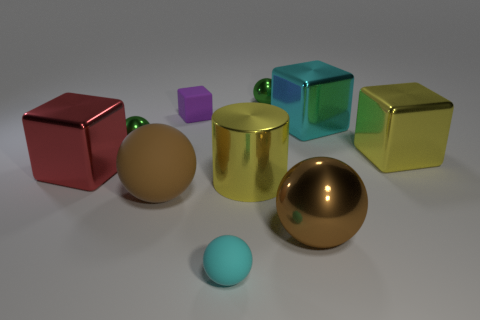Are these objects representing something symbolic, or are they simply a random assortment? The objects might not represent anything symbolic inherently; they are likely a collection of shapes rendered to demonstrate lighting, texture, and reflection properties in a 3D modeling environment. However, one could interpret their arrangement and colors artistically if desired.  Could you analyze the composition of the scene in terms of balance and visual weight? The composition is carefully balanced with the larger shapes anchoring the scene, and the smaller shapes leading the eye across the image. The variety in color and size adds visual interest, creating a harmonious yet dynamic arrangement. 